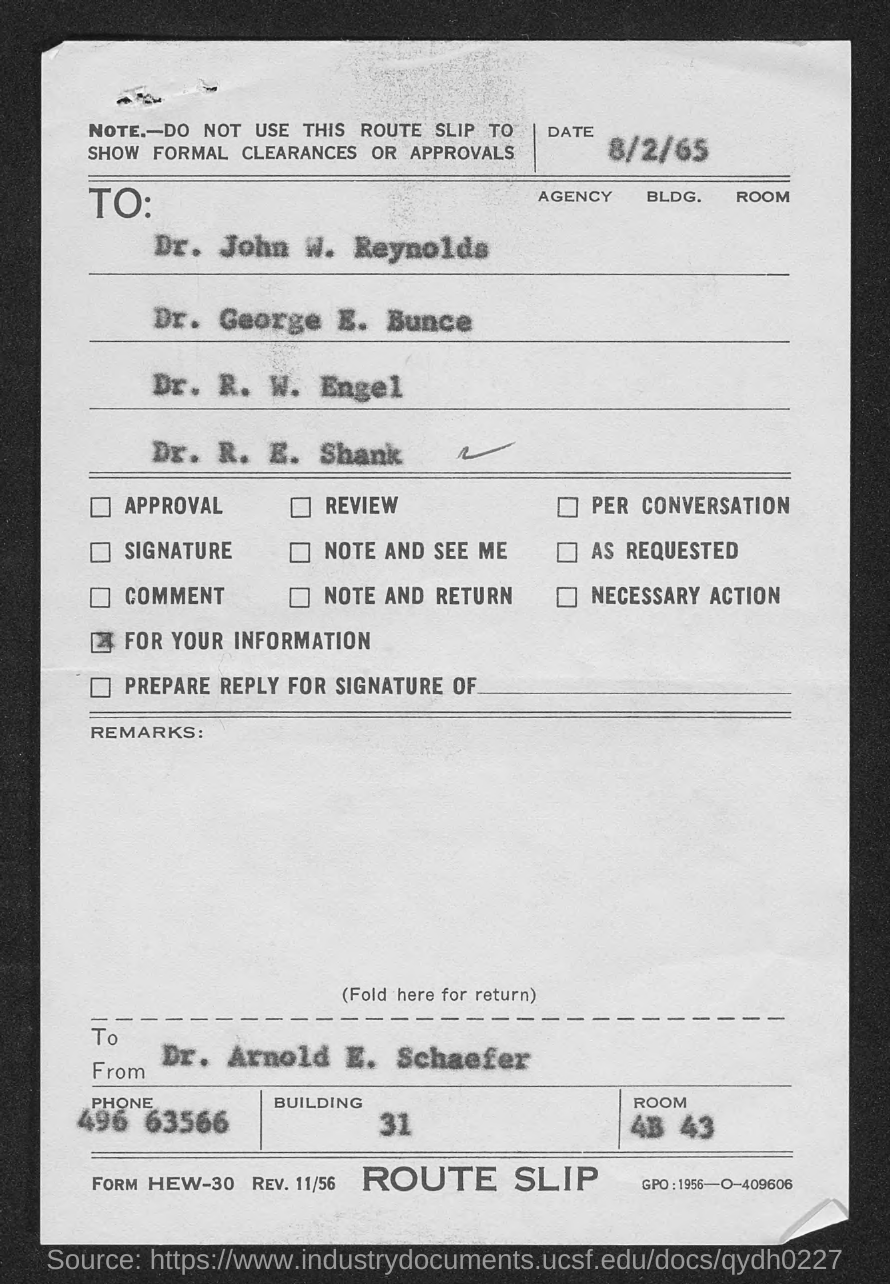What is the date mentioned in this document?
Your answer should be very brief. 8/2/65. Who is the sender of this document?
Your response must be concise. Dr. Arnold E. Schaefer. What is the phone no of Dr. Arnold E. Schaefer?
Your response must be concise. 496 63566. What is the Room no of Dr. Arnold E. Schaefer given in the document?
Make the answer very short. 4B 43. 